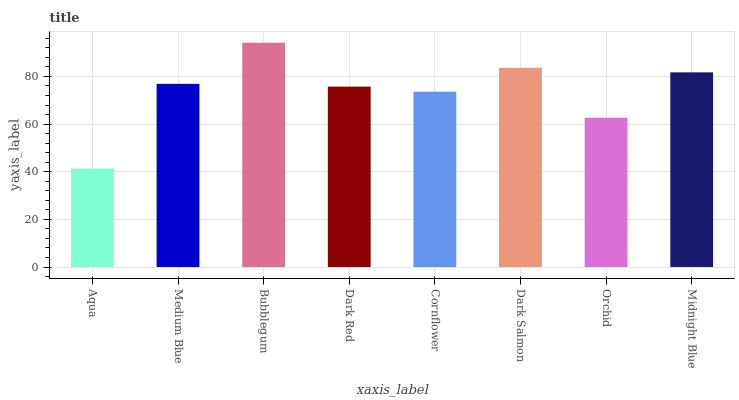Is Aqua the minimum?
Answer yes or no. Yes. Is Bubblegum the maximum?
Answer yes or no. Yes. Is Medium Blue the minimum?
Answer yes or no. No. Is Medium Blue the maximum?
Answer yes or no. No. Is Medium Blue greater than Aqua?
Answer yes or no. Yes. Is Aqua less than Medium Blue?
Answer yes or no. Yes. Is Aqua greater than Medium Blue?
Answer yes or no. No. Is Medium Blue less than Aqua?
Answer yes or no. No. Is Medium Blue the high median?
Answer yes or no. Yes. Is Dark Red the low median?
Answer yes or no. Yes. Is Dark Red the high median?
Answer yes or no. No. Is Dark Salmon the low median?
Answer yes or no. No. 